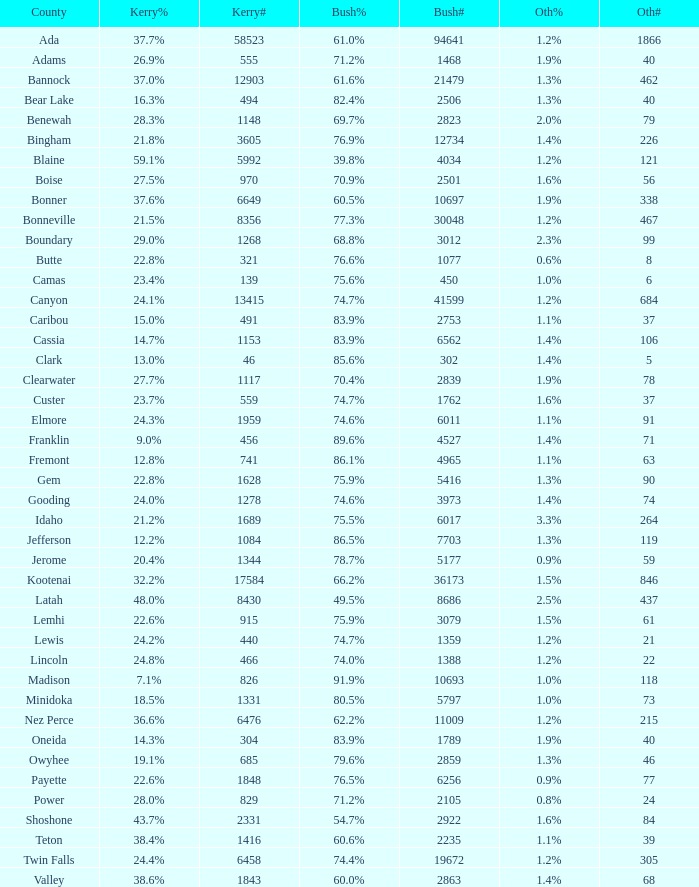How many people voted for Kerry in the county where 8 voted for others? 321.0. 